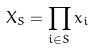Convert formula to latex. <formula><loc_0><loc_0><loc_500><loc_500>X _ { S } = \prod _ { i \in S } x _ { i }</formula> 